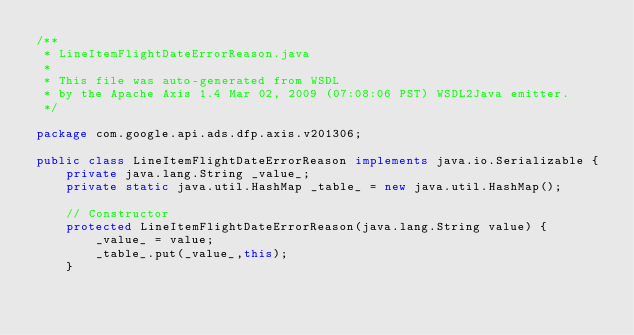<code> <loc_0><loc_0><loc_500><loc_500><_Java_>/**
 * LineItemFlightDateErrorReason.java
 *
 * This file was auto-generated from WSDL
 * by the Apache Axis 1.4 Mar 02, 2009 (07:08:06 PST) WSDL2Java emitter.
 */

package com.google.api.ads.dfp.axis.v201306;

public class LineItemFlightDateErrorReason implements java.io.Serializable {
    private java.lang.String _value_;
    private static java.util.HashMap _table_ = new java.util.HashMap();

    // Constructor
    protected LineItemFlightDateErrorReason(java.lang.String value) {
        _value_ = value;
        _table_.put(_value_,this);
    }
</code> 